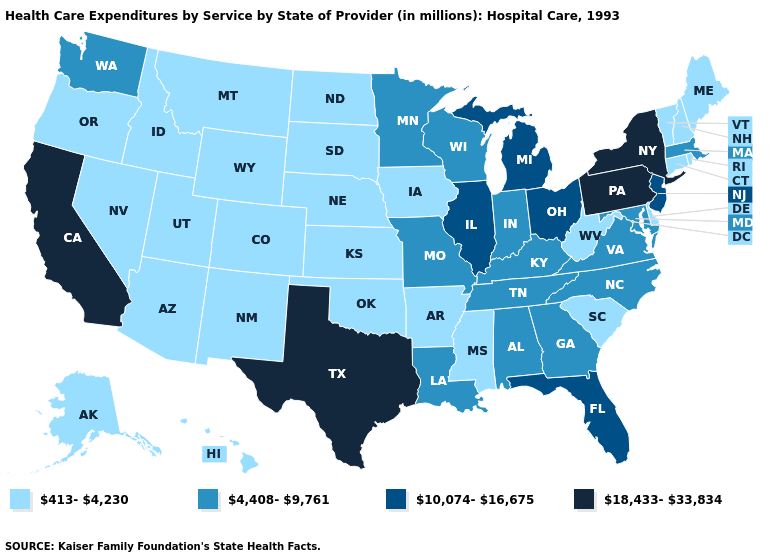Is the legend a continuous bar?
Answer briefly. No. Which states have the lowest value in the Northeast?
Short answer required. Connecticut, Maine, New Hampshire, Rhode Island, Vermont. What is the lowest value in the South?
Answer briefly. 413-4,230. Name the states that have a value in the range 18,433-33,834?
Write a very short answer. California, New York, Pennsylvania, Texas. How many symbols are there in the legend?
Be succinct. 4. What is the lowest value in the MidWest?
Write a very short answer. 413-4,230. Does Maine have the same value as Minnesota?
Give a very brief answer. No. Which states have the lowest value in the USA?
Concise answer only. Alaska, Arizona, Arkansas, Colorado, Connecticut, Delaware, Hawaii, Idaho, Iowa, Kansas, Maine, Mississippi, Montana, Nebraska, Nevada, New Hampshire, New Mexico, North Dakota, Oklahoma, Oregon, Rhode Island, South Carolina, South Dakota, Utah, Vermont, West Virginia, Wyoming. Which states have the lowest value in the MidWest?
Give a very brief answer. Iowa, Kansas, Nebraska, North Dakota, South Dakota. What is the value of North Carolina?
Give a very brief answer. 4,408-9,761. Among the states that border Delaware , which have the lowest value?
Be succinct. Maryland. Among the states that border Nevada , does California have the lowest value?
Short answer required. No. Which states hav the highest value in the South?
Quick response, please. Texas. What is the value of South Carolina?
Answer briefly. 413-4,230. 